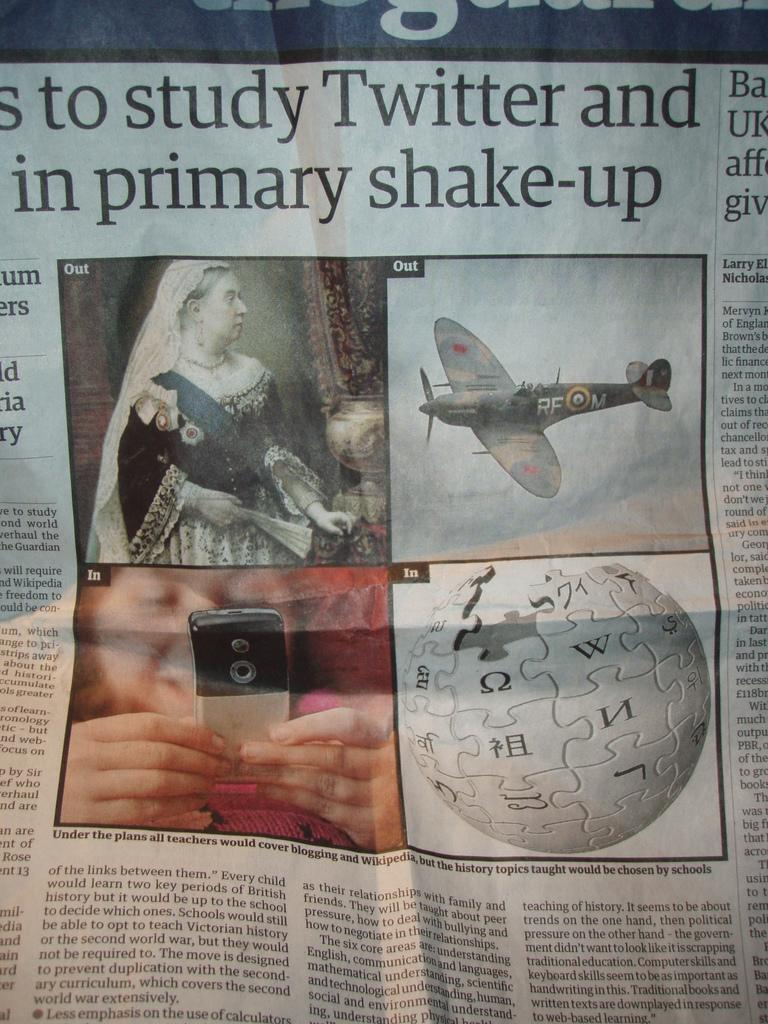What is the main object in the image? There is a newspaper in the image. What can be found within the newspaper? The newspaper contains images and text. What hobbies are the spies engaging in while rubbing the newspaper? There is no mention of spies or hobbies in the image, and the newspaper is not being rubbed. 